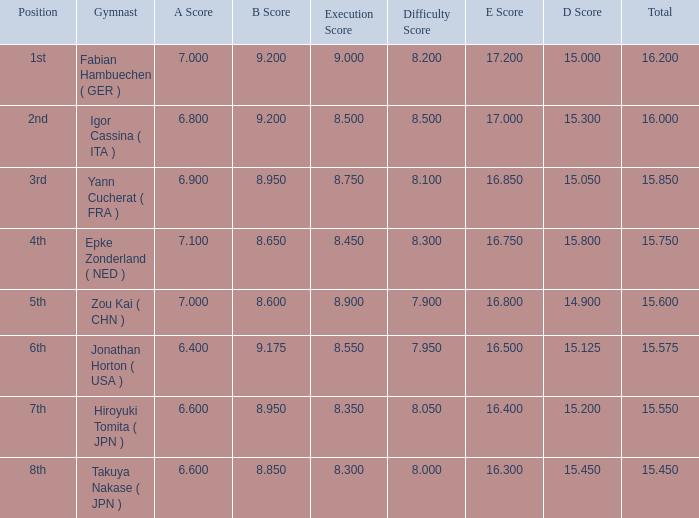What was the total rating that had a score higher than 7 and a b score smaller than 8.65? None. 